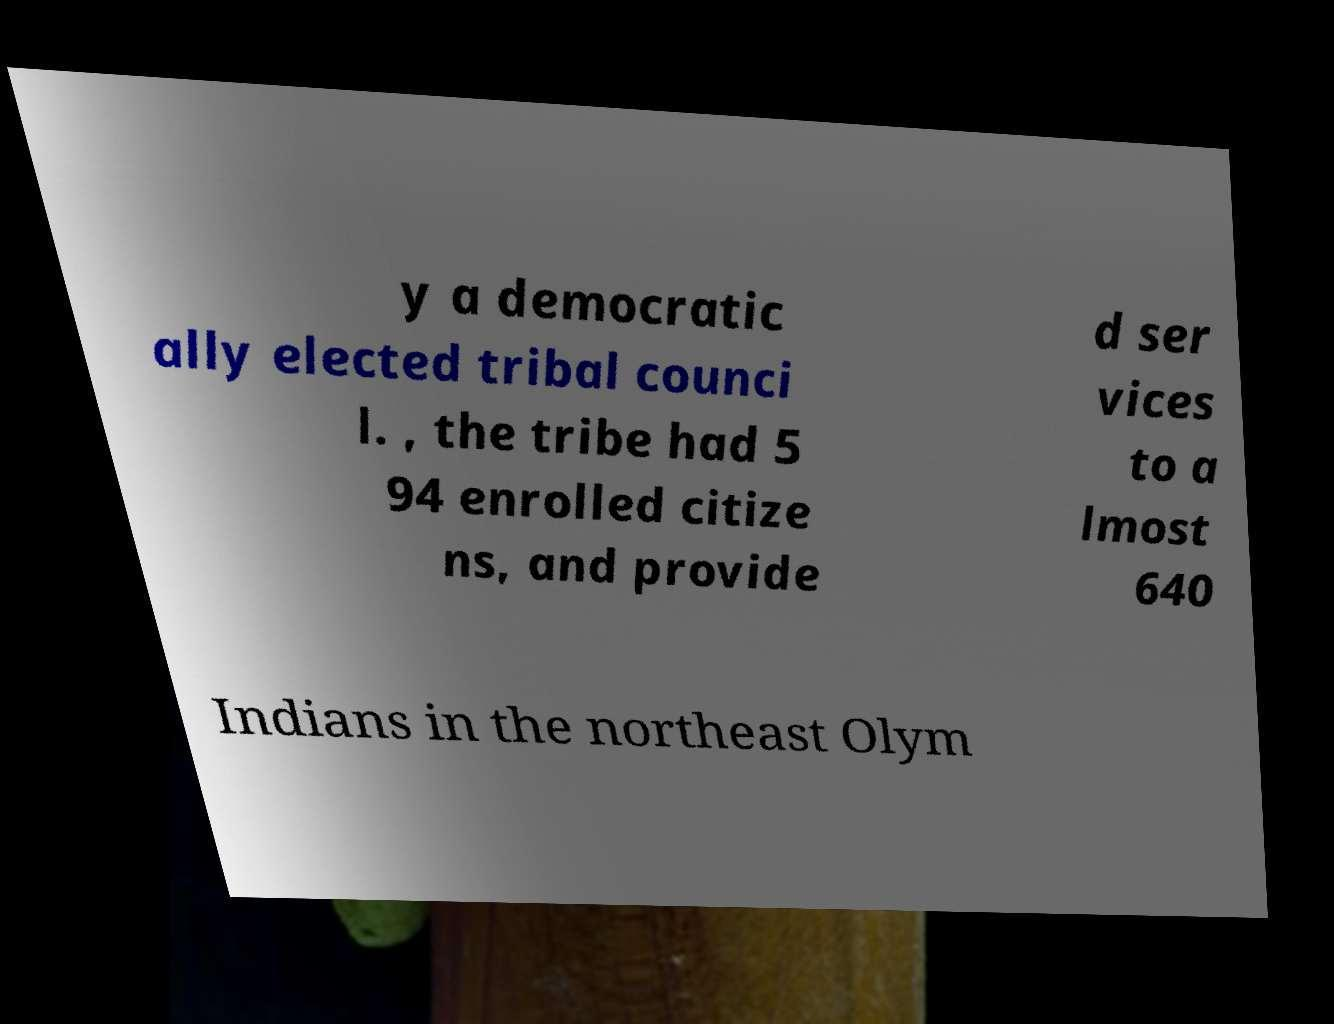Please identify and transcribe the text found in this image. y a democratic ally elected tribal counci l. , the tribe had 5 94 enrolled citize ns, and provide d ser vices to a lmost 640 Indians in the northeast Olym 